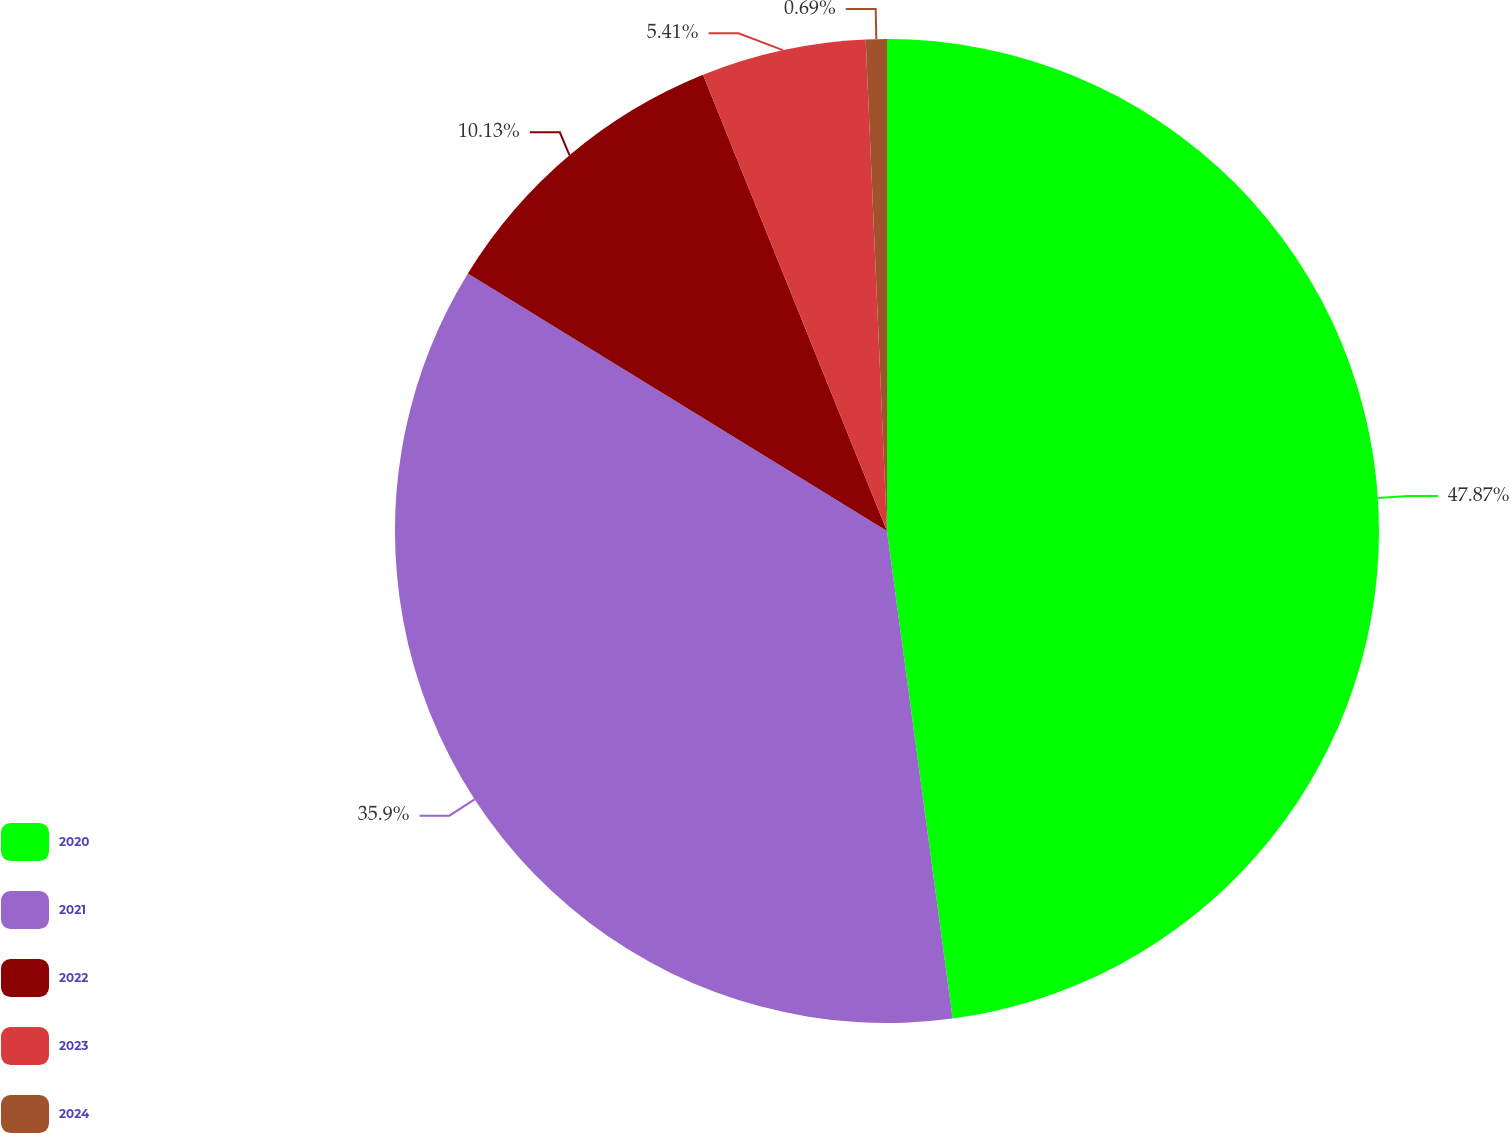Convert chart to OTSL. <chart><loc_0><loc_0><loc_500><loc_500><pie_chart><fcel>2020<fcel>2021<fcel>2022<fcel>2023<fcel>2024<nl><fcel>47.87%<fcel>35.9%<fcel>10.13%<fcel>5.41%<fcel>0.69%<nl></chart> 